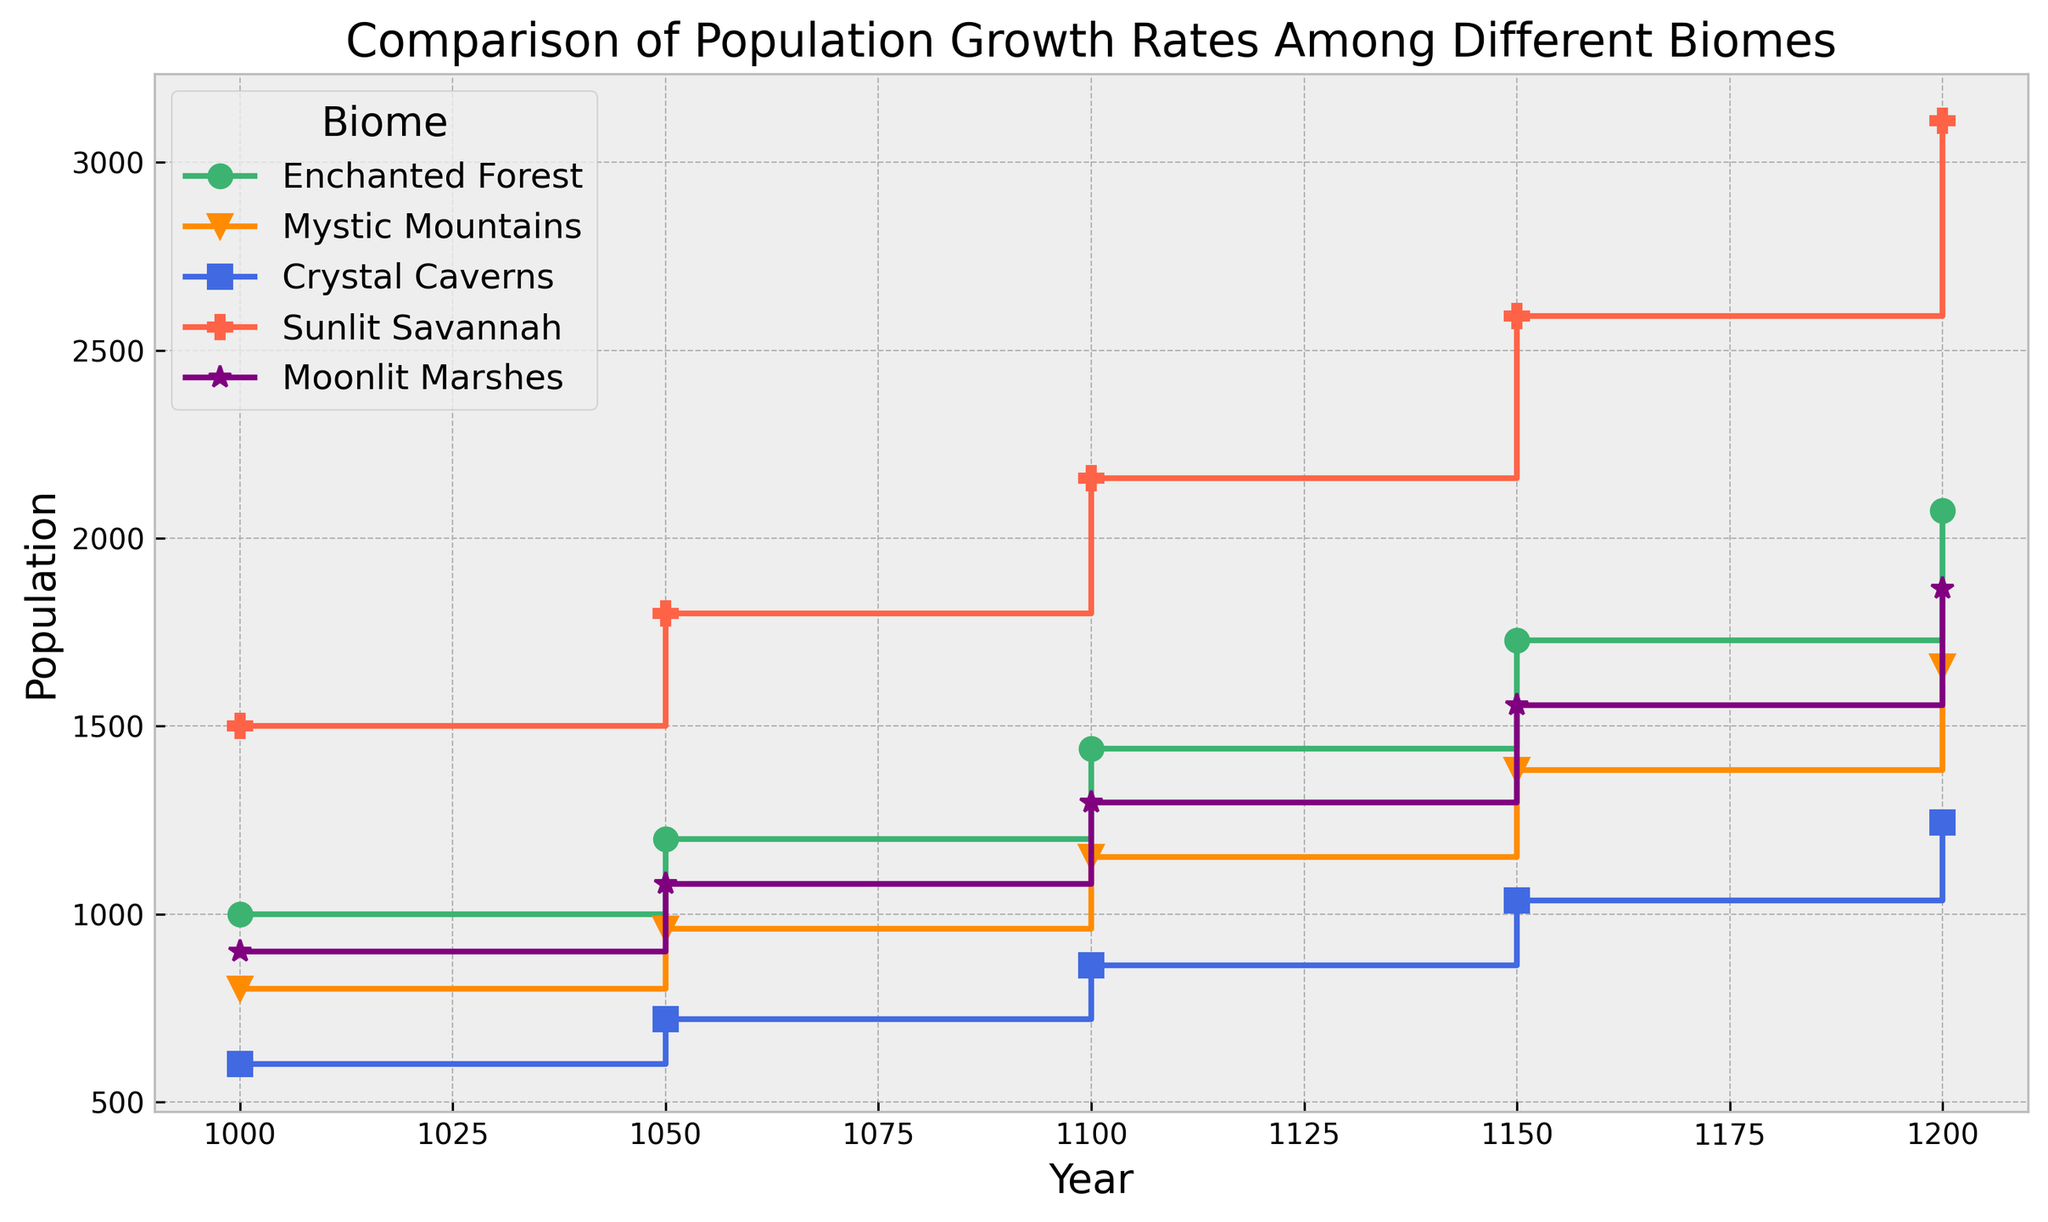What biome shows the highest population growth rate from Year 1000 to Year 1200? To determine the highest population growth rate, compare the ratios of final to initial population for each biome over the period. Enchanted Forest: 2073.6 / 1000 = 2.0736; Mystic Mountains: 1658.88 / 800 = 2.0736; Crystal Caverns: 1244.16 / 600 = 2.0736; Sunlit Savannah: 3110.4 / 1500 = 2.0736; Moonlit Marshes: 1866.24 / 900 = 2.0736. All biomes have the same growth rate.
Answer: All biomes have the same growth rate Which biome has the smallest population in the year 1200? Look at the population values for the year 1200. Enchanted Forest: 2073.6, Mystic Mountains: 1658.88, Crystal Caverns: 1244.16, Sunlit Savannah: 3110.4, Moonlit Marshes: 1866.24. Crystal Caverns has the smallest population.
Answer: Crystal Caverns Between which years did the Sunlit Savannah experience the largest absolute increase in population? Calculate the absolute increase in population for each interval in Sunlit Savannah. 1050-1000: 1800-1500=300; 1100-1050: 2160-1800=360; 1150-1100: 2592-2160=432; 1200-1150: 3110.4-2592=518.4. The largest absolute increase occurs between 1150 and 1200.
Answer: 1150 to 1200 Which biome had an initial population that was closest to its population in the year 1100? Calculate the ratios of the population in year 1100 to the initial population for each biome. Enchanted Forest: 1440 / 1000 = 1.44; Mystic Mountains: 1152 / 800 = 1.44; Crystal Caverns: 864 / 600 = 1.44; Sunlit Savannah: 2160 / 1500 = 1.44; Moonlit Marshes: 1296 / 900 = 1.44. All biomes have equal ratios.
Answer: All biomes have equal ratios Compare the population growth between Enchanted Forest and Crystal Caverns in the year 1100. Which biome grew more in terms of actual population numbers? Calculate the actual population increase for each biome up to 1100. Enchanted Forest: 1440 - 1000 = 440; Crystal Caverns: 864 - 600 = 264. Enchanted Forest grew more.
Answer: Enchanted Forest What color represents the Mystic Mountains in the plot? Look at the legend in the plot to identify the color used for Mystic Mountains. Mystic Mountains is represented in dark orange.
Answer: Dark orange In which interval did Moonlit Marshes surpass Crystal Caverns in population size? Compare population values of Moonlit Marshes and Crystal Caverns at each interval. In 1050, Moonlit Marshes: 1080, Crystal Caverns: 720. By 1050, Moonlit Marshes has already surpassed Crystal Caverns.
Answer: 1000 to 1050 What is the total cumulative population of all biomes in the year 1150? Sum the populations of all biomes in the year 1150. Enchanted Forest: 1728; Mystic Mountains: 1382.4; Crystal Caverns: 1036.8; Sunlit Savannah: 2592; Moonlit Marshes: 1555.2. Total = 1728 + 1382.4 + 1036.8 + 2592 + 1555.2 = 8294.4.
Answer: 8294.4 